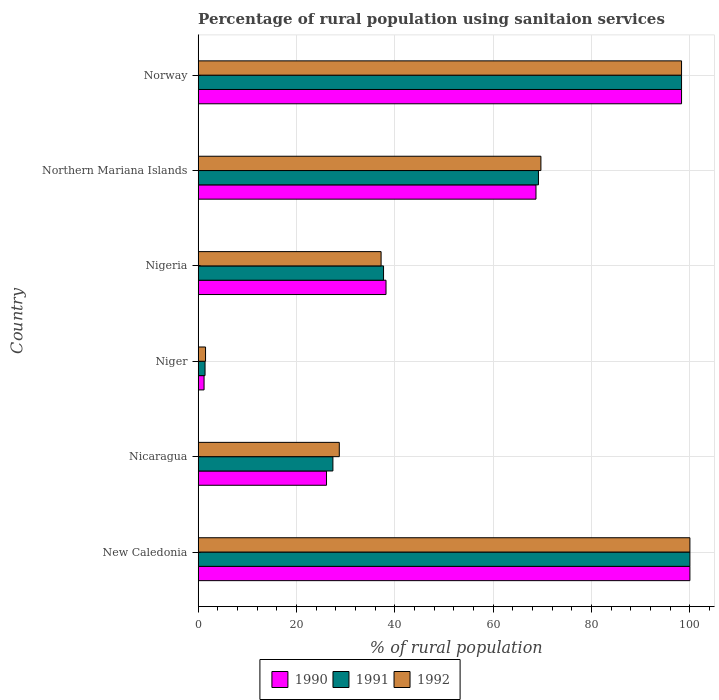How many groups of bars are there?
Your answer should be very brief. 6. Are the number of bars per tick equal to the number of legend labels?
Your response must be concise. Yes. Are the number of bars on each tick of the Y-axis equal?
Offer a terse response. Yes. How many bars are there on the 3rd tick from the top?
Provide a succinct answer. 3. How many bars are there on the 5th tick from the bottom?
Your answer should be very brief. 3. What is the label of the 6th group of bars from the top?
Make the answer very short. New Caledonia. In how many cases, is the number of bars for a given country not equal to the number of legend labels?
Offer a very short reply. 0. What is the percentage of rural population using sanitaion services in 1992 in Nicaragua?
Offer a terse response. 28.7. In which country was the percentage of rural population using sanitaion services in 1991 maximum?
Offer a very short reply. New Caledonia. In which country was the percentage of rural population using sanitaion services in 1990 minimum?
Make the answer very short. Niger. What is the total percentage of rural population using sanitaion services in 1992 in the graph?
Make the answer very short. 335.4. What is the difference between the percentage of rural population using sanitaion services in 1990 in Niger and that in Nigeria?
Ensure brevity in your answer.  -37. What is the difference between the percentage of rural population using sanitaion services in 1992 in Nicaragua and the percentage of rural population using sanitaion services in 1991 in Norway?
Ensure brevity in your answer.  -69.6. What is the average percentage of rural population using sanitaion services in 1992 per country?
Provide a short and direct response. 55.9. What is the difference between the percentage of rural population using sanitaion services in 1992 and percentage of rural population using sanitaion services in 1991 in Nicaragua?
Ensure brevity in your answer.  1.3. In how many countries, is the percentage of rural population using sanitaion services in 1992 greater than 100 %?
Offer a terse response. 0. What is the ratio of the percentage of rural population using sanitaion services in 1991 in Niger to that in Norway?
Your response must be concise. 0.01. Is the percentage of rural population using sanitaion services in 1991 in New Caledonia less than that in Norway?
Make the answer very short. No. What is the difference between the highest and the second highest percentage of rural population using sanitaion services in 1990?
Make the answer very short. 1.7. What is the difference between the highest and the lowest percentage of rural population using sanitaion services in 1992?
Provide a short and direct response. 98.5. In how many countries, is the percentage of rural population using sanitaion services in 1990 greater than the average percentage of rural population using sanitaion services in 1990 taken over all countries?
Your answer should be very brief. 3. How many countries are there in the graph?
Offer a terse response. 6. What is the difference between two consecutive major ticks on the X-axis?
Your answer should be compact. 20. Are the values on the major ticks of X-axis written in scientific E-notation?
Offer a very short reply. No. Does the graph contain any zero values?
Keep it short and to the point. No. Where does the legend appear in the graph?
Your answer should be very brief. Bottom center. How are the legend labels stacked?
Give a very brief answer. Horizontal. What is the title of the graph?
Make the answer very short. Percentage of rural population using sanitaion services. What is the label or title of the X-axis?
Offer a very short reply. % of rural population. What is the label or title of the Y-axis?
Offer a terse response. Country. What is the % of rural population in 1990 in New Caledonia?
Your answer should be compact. 100. What is the % of rural population in 1992 in New Caledonia?
Offer a very short reply. 100. What is the % of rural population of 1990 in Nicaragua?
Your answer should be very brief. 26.1. What is the % of rural population in 1991 in Nicaragua?
Make the answer very short. 27.4. What is the % of rural population in 1992 in Nicaragua?
Provide a succinct answer. 28.7. What is the % of rural population in 1990 in Niger?
Offer a terse response. 1.2. What is the % of rural population in 1990 in Nigeria?
Provide a short and direct response. 38.2. What is the % of rural population in 1991 in Nigeria?
Ensure brevity in your answer.  37.7. What is the % of rural population of 1992 in Nigeria?
Offer a very short reply. 37.2. What is the % of rural population of 1990 in Northern Mariana Islands?
Your answer should be compact. 68.7. What is the % of rural population of 1991 in Northern Mariana Islands?
Your response must be concise. 69.2. What is the % of rural population of 1992 in Northern Mariana Islands?
Offer a very short reply. 69.7. What is the % of rural population in 1990 in Norway?
Your answer should be very brief. 98.3. What is the % of rural population in 1991 in Norway?
Your answer should be compact. 98.3. What is the % of rural population in 1992 in Norway?
Provide a succinct answer. 98.3. Across all countries, what is the minimum % of rural population of 1991?
Provide a succinct answer. 1.4. What is the total % of rural population in 1990 in the graph?
Provide a short and direct response. 332.5. What is the total % of rural population in 1991 in the graph?
Make the answer very short. 334. What is the total % of rural population of 1992 in the graph?
Your response must be concise. 335.4. What is the difference between the % of rural population of 1990 in New Caledonia and that in Nicaragua?
Give a very brief answer. 73.9. What is the difference between the % of rural population in 1991 in New Caledonia and that in Nicaragua?
Your answer should be very brief. 72.6. What is the difference between the % of rural population of 1992 in New Caledonia and that in Nicaragua?
Offer a very short reply. 71.3. What is the difference between the % of rural population of 1990 in New Caledonia and that in Niger?
Your answer should be compact. 98.8. What is the difference between the % of rural population of 1991 in New Caledonia and that in Niger?
Offer a very short reply. 98.6. What is the difference between the % of rural population in 1992 in New Caledonia and that in Niger?
Offer a terse response. 98.5. What is the difference between the % of rural population in 1990 in New Caledonia and that in Nigeria?
Keep it short and to the point. 61.8. What is the difference between the % of rural population of 1991 in New Caledonia and that in Nigeria?
Provide a short and direct response. 62.3. What is the difference between the % of rural population in 1992 in New Caledonia and that in Nigeria?
Your answer should be compact. 62.8. What is the difference between the % of rural population of 1990 in New Caledonia and that in Northern Mariana Islands?
Offer a very short reply. 31.3. What is the difference between the % of rural population in 1991 in New Caledonia and that in Northern Mariana Islands?
Give a very brief answer. 30.8. What is the difference between the % of rural population in 1992 in New Caledonia and that in Northern Mariana Islands?
Offer a very short reply. 30.3. What is the difference between the % of rural population in 1991 in New Caledonia and that in Norway?
Give a very brief answer. 1.7. What is the difference between the % of rural population of 1992 in New Caledonia and that in Norway?
Keep it short and to the point. 1.7. What is the difference between the % of rural population of 1990 in Nicaragua and that in Niger?
Your answer should be very brief. 24.9. What is the difference between the % of rural population of 1991 in Nicaragua and that in Niger?
Provide a short and direct response. 26. What is the difference between the % of rural population in 1992 in Nicaragua and that in Niger?
Keep it short and to the point. 27.2. What is the difference between the % of rural population in 1990 in Nicaragua and that in Nigeria?
Give a very brief answer. -12.1. What is the difference between the % of rural population in 1991 in Nicaragua and that in Nigeria?
Make the answer very short. -10.3. What is the difference between the % of rural population of 1990 in Nicaragua and that in Northern Mariana Islands?
Make the answer very short. -42.6. What is the difference between the % of rural population in 1991 in Nicaragua and that in Northern Mariana Islands?
Offer a very short reply. -41.8. What is the difference between the % of rural population in 1992 in Nicaragua and that in Northern Mariana Islands?
Your response must be concise. -41. What is the difference between the % of rural population in 1990 in Nicaragua and that in Norway?
Make the answer very short. -72.2. What is the difference between the % of rural population in 1991 in Nicaragua and that in Norway?
Your answer should be compact. -70.9. What is the difference between the % of rural population in 1992 in Nicaragua and that in Norway?
Give a very brief answer. -69.6. What is the difference between the % of rural population of 1990 in Niger and that in Nigeria?
Give a very brief answer. -37. What is the difference between the % of rural population of 1991 in Niger and that in Nigeria?
Your answer should be very brief. -36.3. What is the difference between the % of rural population in 1992 in Niger and that in Nigeria?
Ensure brevity in your answer.  -35.7. What is the difference between the % of rural population in 1990 in Niger and that in Northern Mariana Islands?
Provide a succinct answer. -67.5. What is the difference between the % of rural population in 1991 in Niger and that in Northern Mariana Islands?
Your answer should be very brief. -67.8. What is the difference between the % of rural population in 1992 in Niger and that in Northern Mariana Islands?
Your answer should be compact. -68.2. What is the difference between the % of rural population of 1990 in Niger and that in Norway?
Offer a very short reply. -97.1. What is the difference between the % of rural population in 1991 in Niger and that in Norway?
Provide a short and direct response. -96.9. What is the difference between the % of rural population of 1992 in Niger and that in Norway?
Offer a terse response. -96.8. What is the difference between the % of rural population in 1990 in Nigeria and that in Northern Mariana Islands?
Give a very brief answer. -30.5. What is the difference between the % of rural population in 1991 in Nigeria and that in Northern Mariana Islands?
Provide a succinct answer. -31.5. What is the difference between the % of rural population in 1992 in Nigeria and that in Northern Mariana Islands?
Your answer should be compact. -32.5. What is the difference between the % of rural population of 1990 in Nigeria and that in Norway?
Offer a terse response. -60.1. What is the difference between the % of rural population of 1991 in Nigeria and that in Norway?
Offer a very short reply. -60.6. What is the difference between the % of rural population of 1992 in Nigeria and that in Norway?
Make the answer very short. -61.1. What is the difference between the % of rural population of 1990 in Northern Mariana Islands and that in Norway?
Offer a terse response. -29.6. What is the difference between the % of rural population of 1991 in Northern Mariana Islands and that in Norway?
Ensure brevity in your answer.  -29.1. What is the difference between the % of rural population in 1992 in Northern Mariana Islands and that in Norway?
Offer a very short reply. -28.6. What is the difference between the % of rural population in 1990 in New Caledonia and the % of rural population in 1991 in Nicaragua?
Keep it short and to the point. 72.6. What is the difference between the % of rural population in 1990 in New Caledonia and the % of rural population in 1992 in Nicaragua?
Provide a short and direct response. 71.3. What is the difference between the % of rural population of 1991 in New Caledonia and the % of rural population of 1992 in Nicaragua?
Your answer should be very brief. 71.3. What is the difference between the % of rural population in 1990 in New Caledonia and the % of rural population in 1991 in Niger?
Offer a very short reply. 98.6. What is the difference between the % of rural population of 1990 in New Caledonia and the % of rural population of 1992 in Niger?
Make the answer very short. 98.5. What is the difference between the % of rural population in 1991 in New Caledonia and the % of rural population in 1992 in Niger?
Keep it short and to the point. 98.5. What is the difference between the % of rural population of 1990 in New Caledonia and the % of rural population of 1991 in Nigeria?
Offer a very short reply. 62.3. What is the difference between the % of rural population in 1990 in New Caledonia and the % of rural population in 1992 in Nigeria?
Offer a terse response. 62.8. What is the difference between the % of rural population in 1991 in New Caledonia and the % of rural population in 1992 in Nigeria?
Your response must be concise. 62.8. What is the difference between the % of rural population in 1990 in New Caledonia and the % of rural population in 1991 in Northern Mariana Islands?
Your answer should be compact. 30.8. What is the difference between the % of rural population in 1990 in New Caledonia and the % of rural population in 1992 in Northern Mariana Islands?
Make the answer very short. 30.3. What is the difference between the % of rural population in 1991 in New Caledonia and the % of rural population in 1992 in Northern Mariana Islands?
Keep it short and to the point. 30.3. What is the difference between the % of rural population of 1990 in New Caledonia and the % of rural population of 1991 in Norway?
Your answer should be compact. 1.7. What is the difference between the % of rural population in 1990 in Nicaragua and the % of rural population in 1991 in Niger?
Your answer should be very brief. 24.7. What is the difference between the % of rural population in 1990 in Nicaragua and the % of rural population in 1992 in Niger?
Your answer should be compact. 24.6. What is the difference between the % of rural population in 1991 in Nicaragua and the % of rural population in 1992 in Niger?
Offer a very short reply. 25.9. What is the difference between the % of rural population of 1990 in Nicaragua and the % of rural population of 1991 in Nigeria?
Your answer should be very brief. -11.6. What is the difference between the % of rural population in 1990 in Nicaragua and the % of rural population in 1991 in Northern Mariana Islands?
Ensure brevity in your answer.  -43.1. What is the difference between the % of rural population of 1990 in Nicaragua and the % of rural population of 1992 in Northern Mariana Islands?
Offer a terse response. -43.6. What is the difference between the % of rural population of 1991 in Nicaragua and the % of rural population of 1992 in Northern Mariana Islands?
Make the answer very short. -42.3. What is the difference between the % of rural population of 1990 in Nicaragua and the % of rural population of 1991 in Norway?
Provide a succinct answer. -72.2. What is the difference between the % of rural population in 1990 in Nicaragua and the % of rural population in 1992 in Norway?
Offer a very short reply. -72.2. What is the difference between the % of rural population of 1991 in Nicaragua and the % of rural population of 1992 in Norway?
Your response must be concise. -70.9. What is the difference between the % of rural population of 1990 in Niger and the % of rural population of 1991 in Nigeria?
Make the answer very short. -36.5. What is the difference between the % of rural population in 1990 in Niger and the % of rural population in 1992 in Nigeria?
Keep it short and to the point. -36. What is the difference between the % of rural population in 1991 in Niger and the % of rural population in 1992 in Nigeria?
Offer a terse response. -35.8. What is the difference between the % of rural population in 1990 in Niger and the % of rural population in 1991 in Northern Mariana Islands?
Provide a short and direct response. -68. What is the difference between the % of rural population of 1990 in Niger and the % of rural population of 1992 in Northern Mariana Islands?
Offer a very short reply. -68.5. What is the difference between the % of rural population in 1991 in Niger and the % of rural population in 1992 in Northern Mariana Islands?
Ensure brevity in your answer.  -68.3. What is the difference between the % of rural population in 1990 in Niger and the % of rural population in 1991 in Norway?
Your answer should be very brief. -97.1. What is the difference between the % of rural population in 1990 in Niger and the % of rural population in 1992 in Norway?
Make the answer very short. -97.1. What is the difference between the % of rural population of 1991 in Niger and the % of rural population of 1992 in Norway?
Give a very brief answer. -96.9. What is the difference between the % of rural population of 1990 in Nigeria and the % of rural population of 1991 in Northern Mariana Islands?
Provide a short and direct response. -31. What is the difference between the % of rural population in 1990 in Nigeria and the % of rural population in 1992 in Northern Mariana Islands?
Provide a short and direct response. -31.5. What is the difference between the % of rural population of 1991 in Nigeria and the % of rural population of 1992 in Northern Mariana Islands?
Your answer should be very brief. -32. What is the difference between the % of rural population of 1990 in Nigeria and the % of rural population of 1991 in Norway?
Your response must be concise. -60.1. What is the difference between the % of rural population of 1990 in Nigeria and the % of rural population of 1992 in Norway?
Give a very brief answer. -60.1. What is the difference between the % of rural population of 1991 in Nigeria and the % of rural population of 1992 in Norway?
Offer a very short reply. -60.6. What is the difference between the % of rural population of 1990 in Northern Mariana Islands and the % of rural population of 1991 in Norway?
Your response must be concise. -29.6. What is the difference between the % of rural population in 1990 in Northern Mariana Islands and the % of rural population in 1992 in Norway?
Provide a short and direct response. -29.6. What is the difference between the % of rural population in 1991 in Northern Mariana Islands and the % of rural population in 1992 in Norway?
Your answer should be very brief. -29.1. What is the average % of rural population in 1990 per country?
Your answer should be compact. 55.42. What is the average % of rural population in 1991 per country?
Your response must be concise. 55.67. What is the average % of rural population of 1992 per country?
Your answer should be very brief. 55.9. What is the difference between the % of rural population in 1990 and % of rural population in 1991 in New Caledonia?
Ensure brevity in your answer.  0. What is the difference between the % of rural population in 1990 and % of rural population in 1992 in New Caledonia?
Give a very brief answer. 0. What is the difference between the % of rural population in 1991 and % of rural population in 1992 in Nicaragua?
Ensure brevity in your answer.  -1.3. What is the difference between the % of rural population in 1990 and % of rural population in 1991 in Niger?
Provide a short and direct response. -0.2. What is the difference between the % of rural population in 1990 and % of rural population in 1992 in Niger?
Make the answer very short. -0.3. What is the difference between the % of rural population in 1990 and % of rural population in 1991 in Northern Mariana Islands?
Your answer should be very brief. -0.5. What is the difference between the % of rural population of 1991 and % of rural population of 1992 in Northern Mariana Islands?
Offer a very short reply. -0.5. What is the difference between the % of rural population of 1990 and % of rural population of 1992 in Norway?
Provide a succinct answer. 0. What is the ratio of the % of rural population in 1990 in New Caledonia to that in Nicaragua?
Your answer should be compact. 3.83. What is the ratio of the % of rural population of 1991 in New Caledonia to that in Nicaragua?
Offer a very short reply. 3.65. What is the ratio of the % of rural population in 1992 in New Caledonia to that in Nicaragua?
Make the answer very short. 3.48. What is the ratio of the % of rural population of 1990 in New Caledonia to that in Niger?
Give a very brief answer. 83.33. What is the ratio of the % of rural population of 1991 in New Caledonia to that in Niger?
Ensure brevity in your answer.  71.43. What is the ratio of the % of rural population of 1992 in New Caledonia to that in Niger?
Keep it short and to the point. 66.67. What is the ratio of the % of rural population in 1990 in New Caledonia to that in Nigeria?
Ensure brevity in your answer.  2.62. What is the ratio of the % of rural population in 1991 in New Caledonia to that in Nigeria?
Offer a terse response. 2.65. What is the ratio of the % of rural population in 1992 in New Caledonia to that in Nigeria?
Offer a very short reply. 2.69. What is the ratio of the % of rural population of 1990 in New Caledonia to that in Northern Mariana Islands?
Your response must be concise. 1.46. What is the ratio of the % of rural population of 1991 in New Caledonia to that in Northern Mariana Islands?
Your answer should be compact. 1.45. What is the ratio of the % of rural population of 1992 in New Caledonia to that in Northern Mariana Islands?
Offer a terse response. 1.43. What is the ratio of the % of rural population in 1990 in New Caledonia to that in Norway?
Offer a very short reply. 1.02. What is the ratio of the % of rural population of 1991 in New Caledonia to that in Norway?
Ensure brevity in your answer.  1.02. What is the ratio of the % of rural population in 1992 in New Caledonia to that in Norway?
Make the answer very short. 1.02. What is the ratio of the % of rural population of 1990 in Nicaragua to that in Niger?
Provide a short and direct response. 21.75. What is the ratio of the % of rural population of 1991 in Nicaragua to that in Niger?
Your response must be concise. 19.57. What is the ratio of the % of rural population in 1992 in Nicaragua to that in Niger?
Your answer should be very brief. 19.13. What is the ratio of the % of rural population of 1990 in Nicaragua to that in Nigeria?
Offer a very short reply. 0.68. What is the ratio of the % of rural population in 1991 in Nicaragua to that in Nigeria?
Offer a very short reply. 0.73. What is the ratio of the % of rural population of 1992 in Nicaragua to that in Nigeria?
Keep it short and to the point. 0.77. What is the ratio of the % of rural population of 1990 in Nicaragua to that in Northern Mariana Islands?
Provide a succinct answer. 0.38. What is the ratio of the % of rural population of 1991 in Nicaragua to that in Northern Mariana Islands?
Offer a very short reply. 0.4. What is the ratio of the % of rural population in 1992 in Nicaragua to that in Northern Mariana Islands?
Keep it short and to the point. 0.41. What is the ratio of the % of rural population in 1990 in Nicaragua to that in Norway?
Offer a very short reply. 0.27. What is the ratio of the % of rural population of 1991 in Nicaragua to that in Norway?
Give a very brief answer. 0.28. What is the ratio of the % of rural population in 1992 in Nicaragua to that in Norway?
Make the answer very short. 0.29. What is the ratio of the % of rural population in 1990 in Niger to that in Nigeria?
Offer a terse response. 0.03. What is the ratio of the % of rural population in 1991 in Niger to that in Nigeria?
Ensure brevity in your answer.  0.04. What is the ratio of the % of rural population of 1992 in Niger to that in Nigeria?
Provide a short and direct response. 0.04. What is the ratio of the % of rural population in 1990 in Niger to that in Northern Mariana Islands?
Your answer should be compact. 0.02. What is the ratio of the % of rural population of 1991 in Niger to that in Northern Mariana Islands?
Your response must be concise. 0.02. What is the ratio of the % of rural population in 1992 in Niger to that in Northern Mariana Islands?
Keep it short and to the point. 0.02. What is the ratio of the % of rural population in 1990 in Niger to that in Norway?
Your response must be concise. 0.01. What is the ratio of the % of rural population in 1991 in Niger to that in Norway?
Offer a very short reply. 0.01. What is the ratio of the % of rural population of 1992 in Niger to that in Norway?
Provide a short and direct response. 0.02. What is the ratio of the % of rural population of 1990 in Nigeria to that in Northern Mariana Islands?
Keep it short and to the point. 0.56. What is the ratio of the % of rural population of 1991 in Nigeria to that in Northern Mariana Islands?
Offer a very short reply. 0.54. What is the ratio of the % of rural population in 1992 in Nigeria to that in Northern Mariana Islands?
Ensure brevity in your answer.  0.53. What is the ratio of the % of rural population of 1990 in Nigeria to that in Norway?
Your response must be concise. 0.39. What is the ratio of the % of rural population of 1991 in Nigeria to that in Norway?
Ensure brevity in your answer.  0.38. What is the ratio of the % of rural population of 1992 in Nigeria to that in Norway?
Ensure brevity in your answer.  0.38. What is the ratio of the % of rural population of 1990 in Northern Mariana Islands to that in Norway?
Give a very brief answer. 0.7. What is the ratio of the % of rural population in 1991 in Northern Mariana Islands to that in Norway?
Make the answer very short. 0.7. What is the ratio of the % of rural population in 1992 in Northern Mariana Islands to that in Norway?
Offer a terse response. 0.71. What is the difference between the highest and the second highest % of rural population of 1990?
Your response must be concise. 1.7. What is the difference between the highest and the second highest % of rural population of 1992?
Offer a very short reply. 1.7. What is the difference between the highest and the lowest % of rural population in 1990?
Provide a succinct answer. 98.8. What is the difference between the highest and the lowest % of rural population in 1991?
Give a very brief answer. 98.6. What is the difference between the highest and the lowest % of rural population of 1992?
Ensure brevity in your answer.  98.5. 